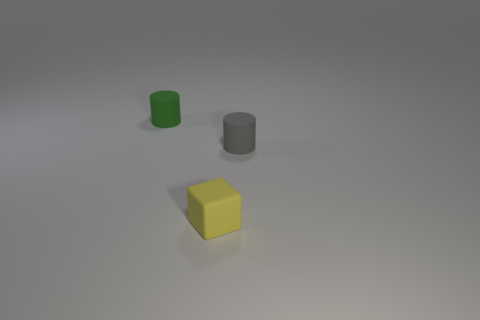Subtract all cubes. How many objects are left? 2 Subtract 1 cubes. How many cubes are left? 0 Subtract all green cylinders. Subtract all brown balls. How many cylinders are left? 1 Subtract all brown spheres. How many green cylinders are left? 1 Subtract all tiny cylinders. Subtract all purple matte spheres. How many objects are left? 1 Add 2 gray objects. How many gray objects are left? 3 Add 3 purple balls. How many purple balls exist? 3 Add 2 yellow blocks. How many objects exist? 5 Subtract 0 blue blocks. How many objects are left? 3 